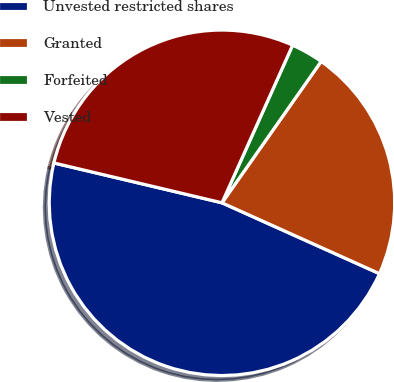Convert chart. <chart><loc_0><loc_0><loc_500><loc_500><pie_chart><fcel>Unvested restricted shares<fcel>Granted<fcel>Forfeited<fcel>Vested<nl><fcel>46.97%<fcel>21.99%<fcel>3.03%<fcel>28.0%<nl></chart> 